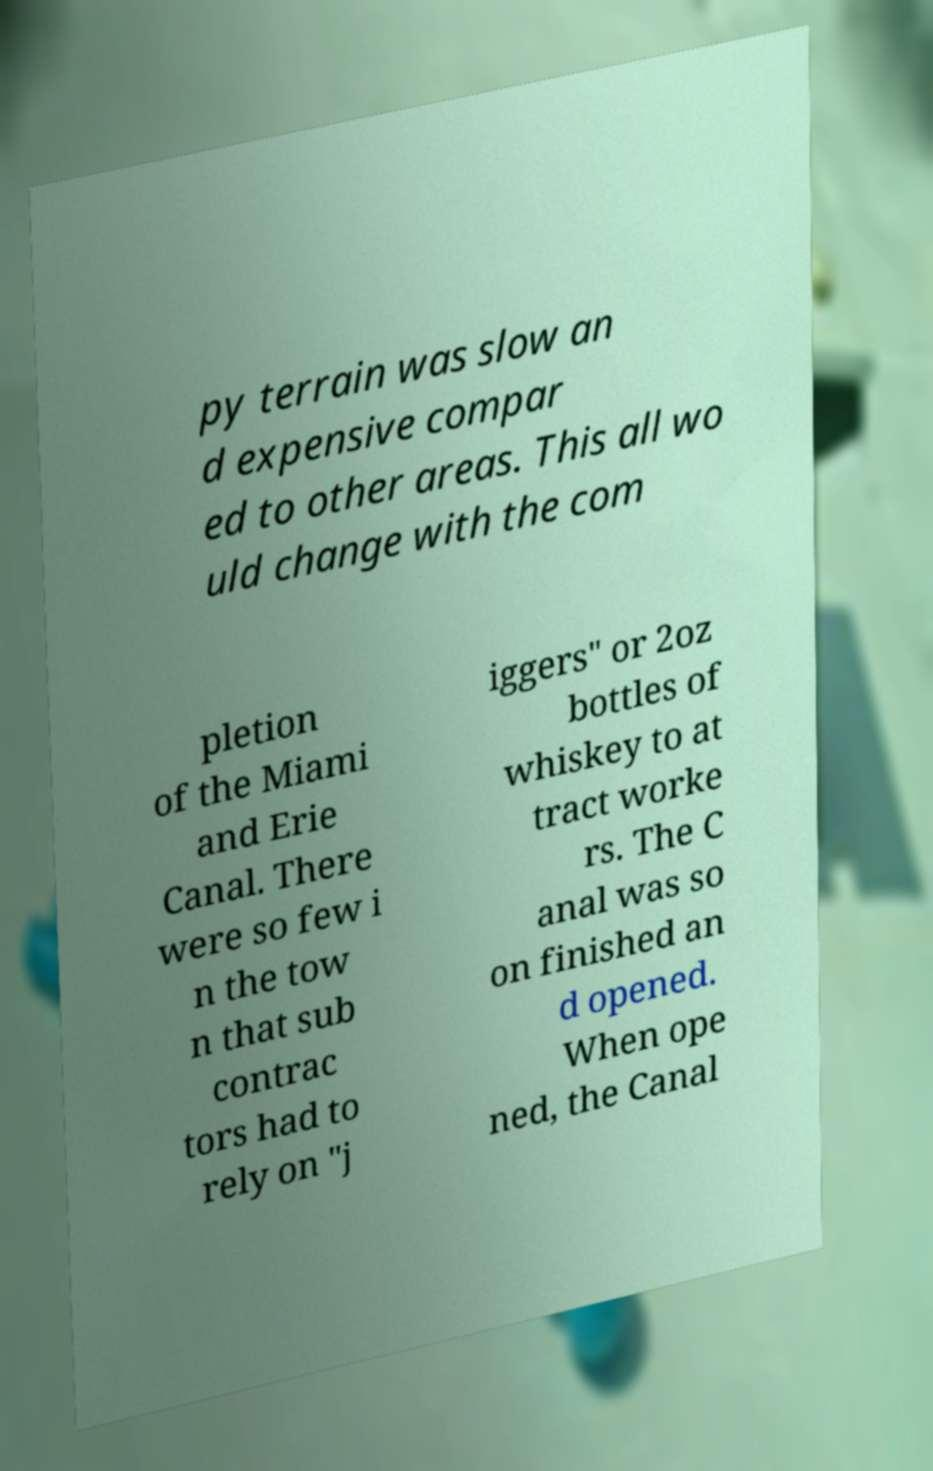Can you accurately transcribe the text from the provided image for me? py terrain was slow an d expensive compar ed to other areas. This all wo uld change with the com pletion of the Miami and Erie Canal. There were so few i n the tow n that sub contrac tors had to rely on "j iggers" or 2oz bottles of whiskey to at tract worke rs. The C anal was so on finished an d opened. When ope ned, the Canal 